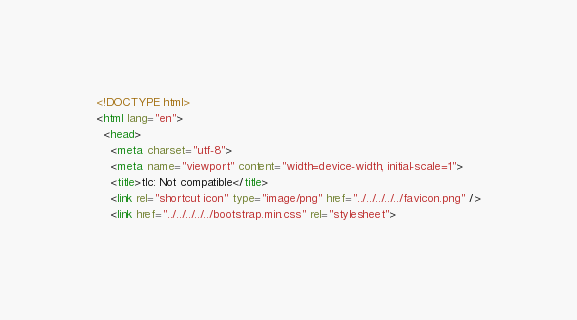<code> <loc_0><loc_0><loc_500><loc_500><_HTML_><!DOCTYPE html>
<html lang="en">
  <head>
    <meta charset="utf-8">
    <meta name="viewport" content="width=device-width, initial-scale=1">
    <title>tlc: Not compatible</title>
    <link rel="shortcut icon" type="image/png" href="../../../../../favicon.png" />
    <link href="../../../../../bootstrap.min.css" rel="stylesheet"></code> 